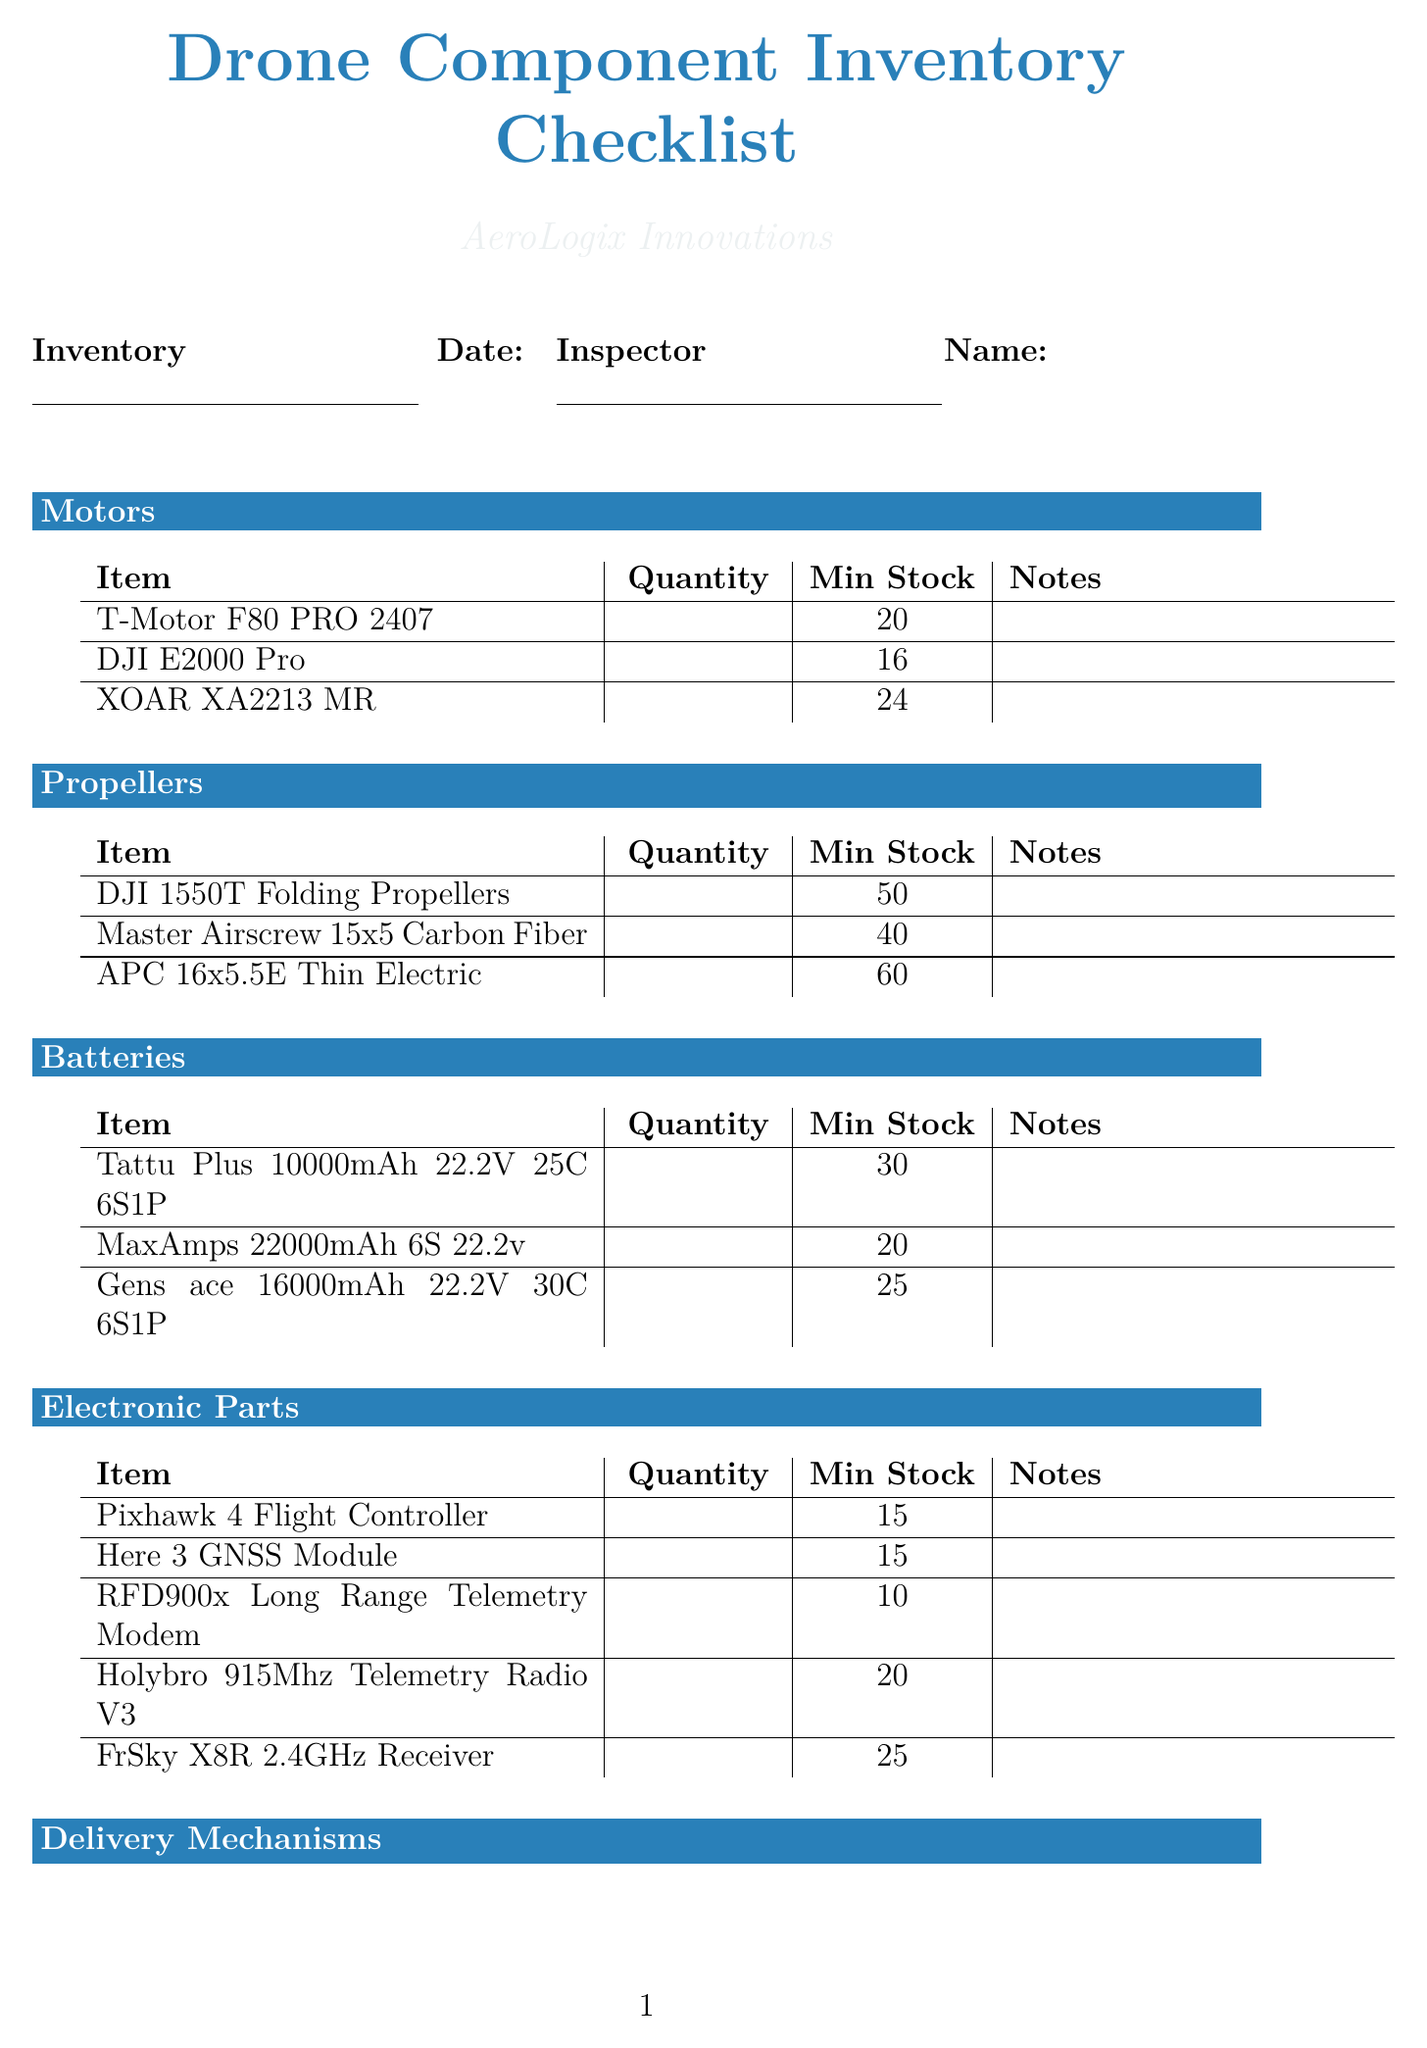what is the company name? The company name is clearly stated at the top of the document under the title.
Answer: AeroLogix Innovations what is the inventory date? The inventory date is mentioned in a blank line next to the label "Inventory Date".
Answer: YYYY-MM-DD who is the inspector? The inspector's name is placed alongside the inventory date under the label "Inspector Name".
Answer: Full Name how many T-Motor F80 PRO 2407 are in stock? The stock quantity for T-Motor F80 PRO 2407 is listed under the "Motors" section.
Answer: 0 what is the minimum stock required for DJI 1550T Folding Propellers? The minimum stock for DJI 1550T Folding Propellers is detailed in the "Propellers" section.
Answer: 50 how many total items are listed under Electronic Parts? The number of items under the "Electronic Parts" section can be counted directly from their line entries.
Answer: 5 which item has the lowest minimum stock requirement in the Batteries category? The item in the Batteries category with the lowest minimum stock requirement can be identified by comparing the numbers.
Answer: MaxAmps 22000mAh 6S 22.2v what is the minimum stock for the Retractable Winch Mechanism? The minimum stock for the Retractable Winch Mechanism can be found in the "Delivery Mechanisms" section.
Answer: 15 how many sensors are listed in the document? The number of sensor items can be counted in the "Sensors" section.
Answer: 3 